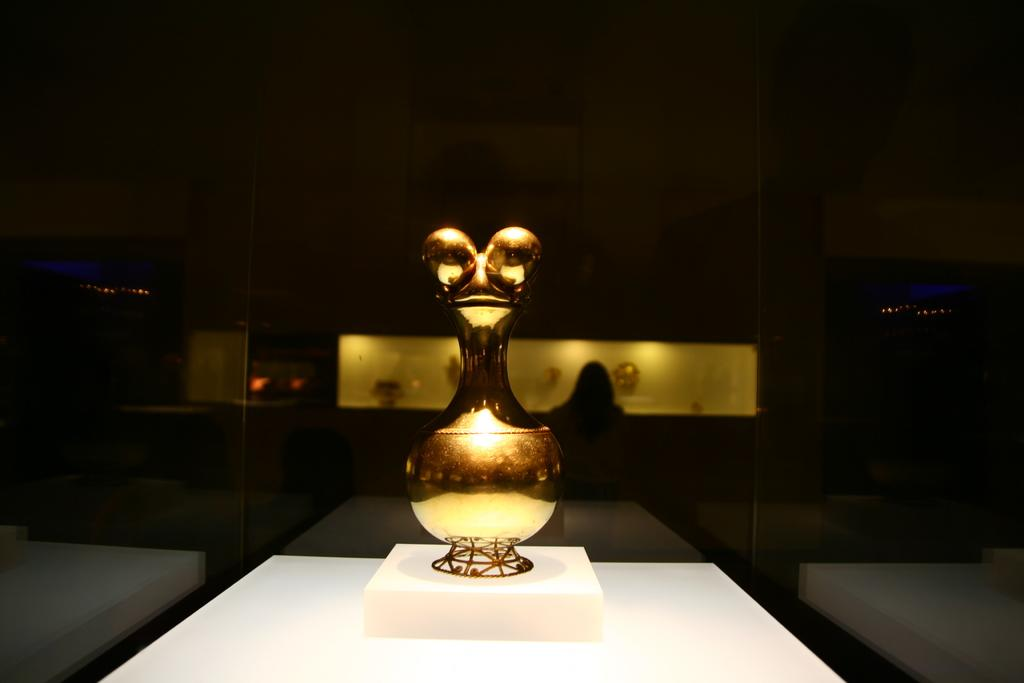What is the main subject of the image? There is an object in the image. What is the color of the object? The object is golden in color. What is the object placed on? The object is placed on a white surface. How many geese are flying over the object in the image? There are no geese present in the image. What sound does the bell make when it is rung in the image? There is no bell present in the image. 